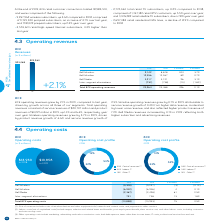According to Bce's financial document, What is the percentage change in the Total BCE operating revenues in 2019? According to the financial document, 2.1%. The relevant text states: "Total BCE operating revenues 23,964 23,468 496 2.1%..." Also, How much did the wireless operating revenues grow by in 2019? According to the financial document, 3.7%. The relevant text states: "Bell Wireless 9,142 8,818 324 3.7%..." Also, What is the amount of $ CHANGE for Bell Wireless in 2019? According to the financial document, 324. The relevant text states: "Bell Wireless 9,142 8,818 324 3.7%..." Also, can you calculate: What is the percentage of operating revenues for Bell Media out of the total BCE operating revenues in 2019? Based on the calculation: 3,217/23,964, the result is 13.42 (percentage). This is based on the information: "Bell Media 3,217 3,121 96 3.1% Total BCE operating revenues 23,964 23,468 496 2.1%..." The key data points involved are: 23,964, 3,217. Also, can you calculate: What is the sum of revenues for Bell Wireless and Bell Wireline in 2018? Based on the calculation: 8,818+12,267, the result is 21085. This is based on the information: "Bell Wireless 9,142 8,818 324 3.7% Bell Wireline 12,356 12,267 89 0.7%..." The key data points involved are: 12,267, 8,818. Also, can you calculate: What is the total amount of revenue for Bell Media in 2018 and 2019? Based on the calculation: 3,217+3,121, the result is 6338. This is based on the information: "Bell Media 3,217 3,121 96 3.1% Bell Media 3,217 3,121 96 3.1%..." The key data points involved are: 3,121, 3,217. 